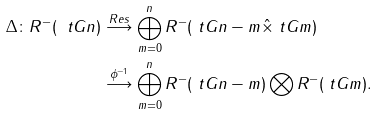<formula> <loc_0><loc_0><loc_500><loc_500>\Delta \colon R ^ { - } ( \ t G n ) & \stackrel { R e s } { \longrightarrow } \bigoplus _ { m = 0 } ^ { n } R ^ { - } ( \ t G { n - m } \hat { \times } \ t G m ) \\ & \stackrel { \phi ^ { - 1 } } { \longrightarrow } \bigoplus _ { m = 0 } ^ { n } R ^ { - } ( \ t G { n - m } ) \bigotimes R ^ { - } ( \ t G m ) .</formula> 